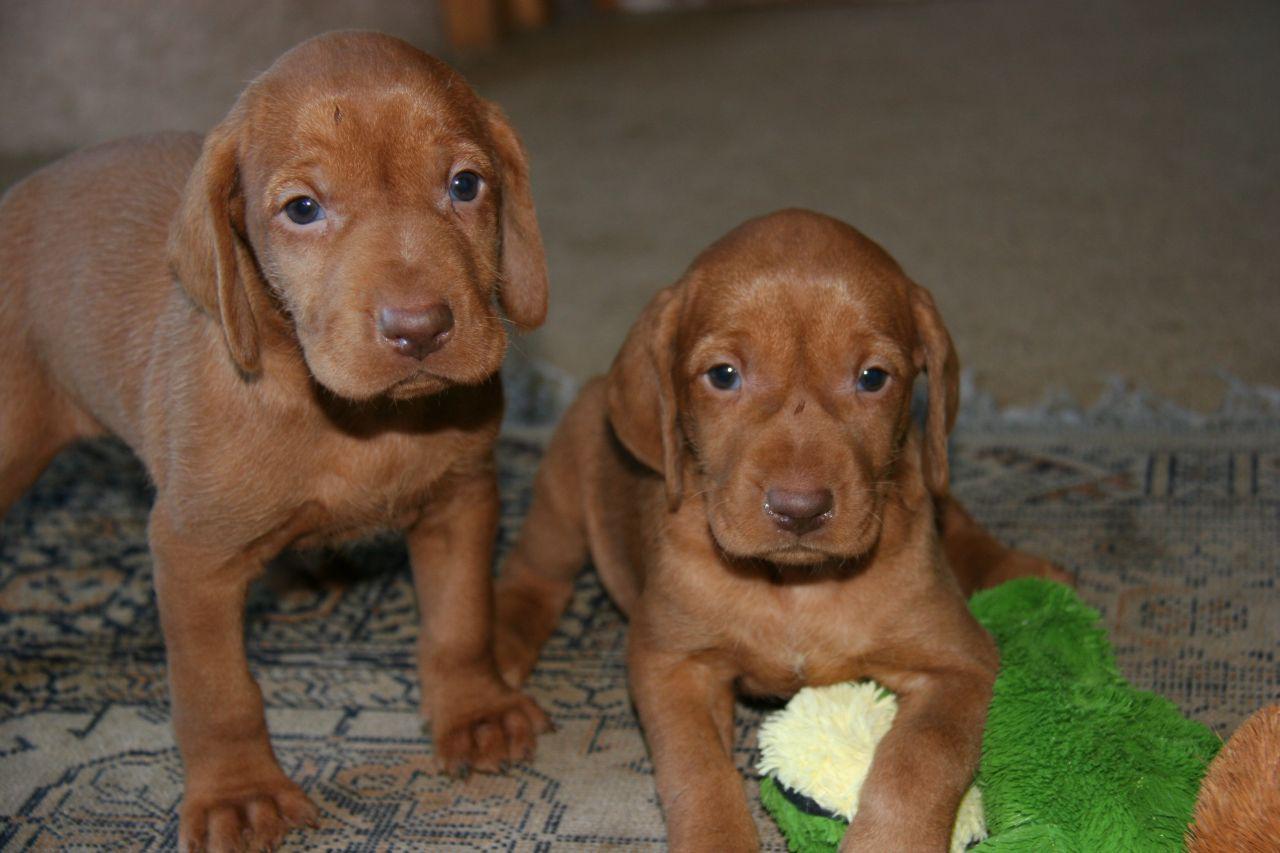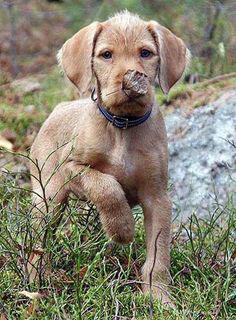The first image is the image on the left, the second image is the image on the right. Analyze the images presented: Is the assertion "There are at least three puppies." valid? Answer yes or no. Yes. The first image is the image on the left, the second image is the image on the right. Evaluate the accuracy of this statement regarding the images: "The right image shows one forward-looking puppy standing on grass with the front paw on the left raised.". Is it true? Answer yes or no. Yes. 